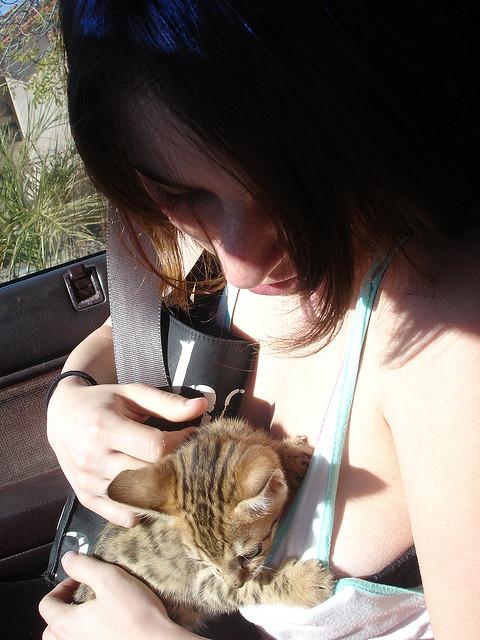Is the cat white?
Be succinct. No. Does this kitten like to be held?
Keep it brief. Yes. Does the woman have a tan?
Be succinct. No. 